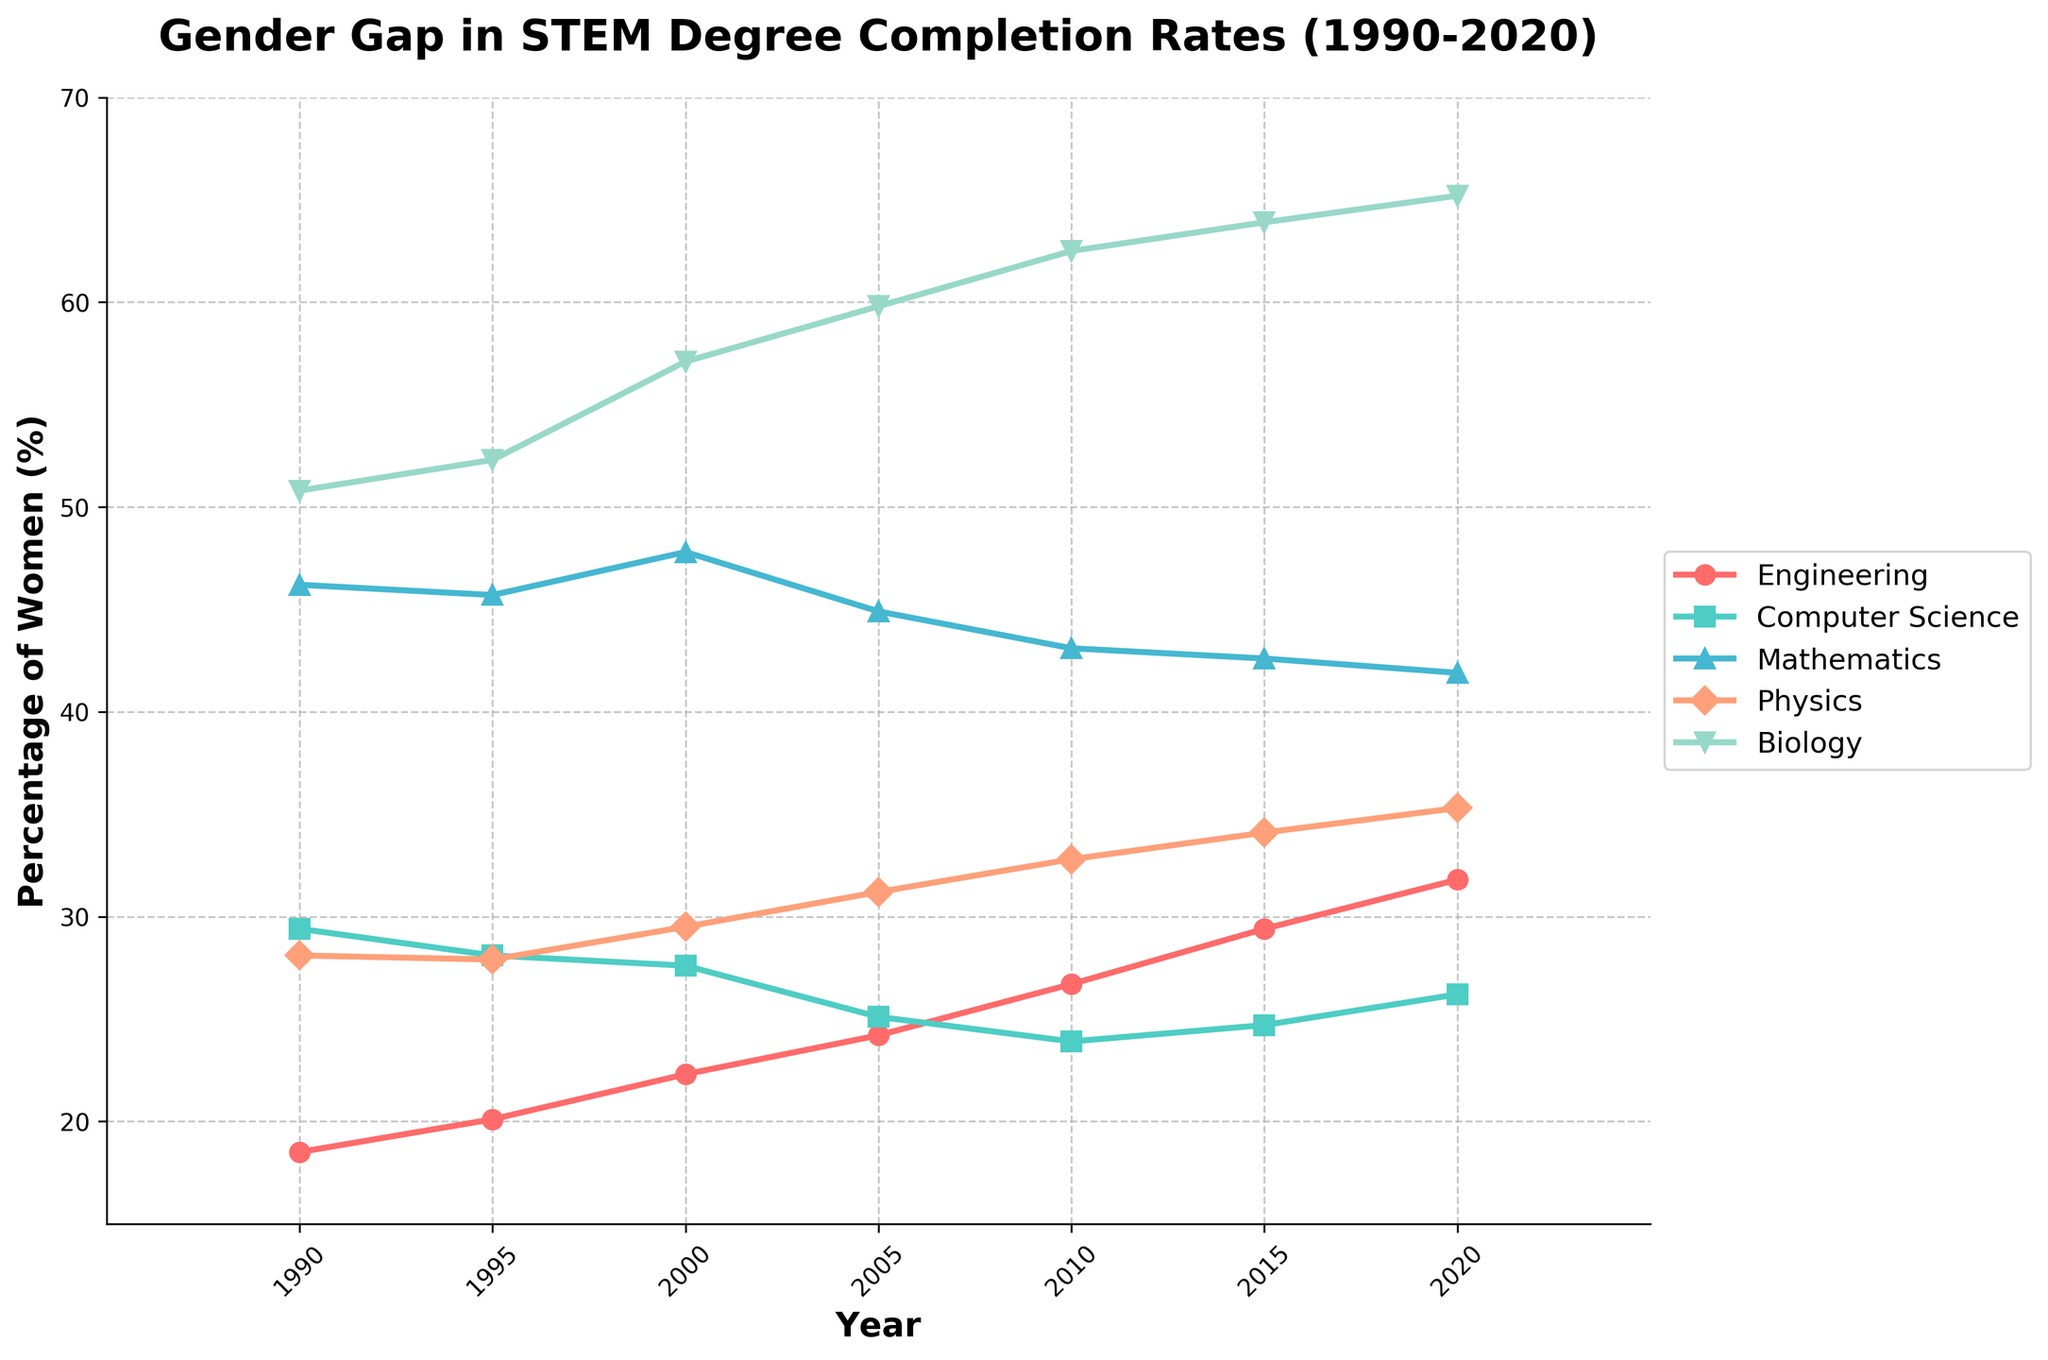What is the trend in the percentage of women completing Engineering degrees from 1990 to 2020? The trend shows a steady increase in the percentage of women completing Engineering degrees from 18.5% in 1990 to 31.8% in 2020, with occasional minor fluctuations. This can be observed by tracking the upward slope of the line representing Engineering over the years.
Answer: Steady increase Which discipline had the highest percentage of women degree completers in 2020? In 2020, Biology had the highest percentage of women degree completers, reaching 65.2%, as evidenced by the highest point on the y-axis among all the disciplines in that year.
Answer: Biology By how much did the percentage of women in Computer Science decrease from 1990 to 2010? In 1990, the percentage of women in Computer Science was 29.4%, and in 2010 it was 23.9%. The decrease can be calculated as 29.4% - 23.9% = 5.5%.
Answer: 5.5% Which disciplines experienced an increase in the percentage of women degree completers every five years from 1990 to 2020? Both Engineering and Biology show a consistent increase in the percentage of women degree completers every five years, as their respective lines continuously rise across each time interval in the chart.
Answer: Engineering and Biology How does the percentage of women in Mathematics in 2000 compare to that in Physics in 2000? In 2000, Mathematics had 47.8% women, while Physics had 29.5%. This indicates that the percentage of women in Mathematics was higher than in Physics by 47.8% - 29.5% = 18.3%.
Answer: Mathematics had 18.3% more women What is the difference in the percentage of women in Biology and Physics in 1995? In 1995, the percentage of women in Biology was 52.3%, and in Physics, it was 27.9%. The difference is 52.3% - 27.9% = 24.4%.
Answer: 24.4% Which discipline had the smallest relative change in the percentage of women degree completers between 1990 and 2020? Mathematics had the smallest relative change in the percentage of women degree completers, decreasing slightly from 46.2% in 1990 to 41.9% in 2020, resulting in a change of 46.2% - 41.9% = 4.3%.
Answer: Mathematics How have the completion rates of women in Computer Science changed relative to the trend in Biology over the years? While the completion rates of women in Biology show a consistent upward trend from 50.8% in 1990 to 65.2% in 2020, Computer Science saw a decline from 29.4% in 1990 to 23.9% in 2010, with a slight increase to 26.2% in 2020. This demonstrates that Biology improved continuously, whereas Computer Science faced a decline before a modest recovery.
Answer: Biology has consistently increased; Computer Science declined and then slightly recovered Between 1995 and 2005, which discipline saw the largest increase in the percentage of women degree completers? Biology saw the largest increase in the percentage of women degree completers between 1995 (52.3%) and 2005 (59.8%), with an increase of 59.8% - 52.3% = 7.5%.
Answer: Biology 